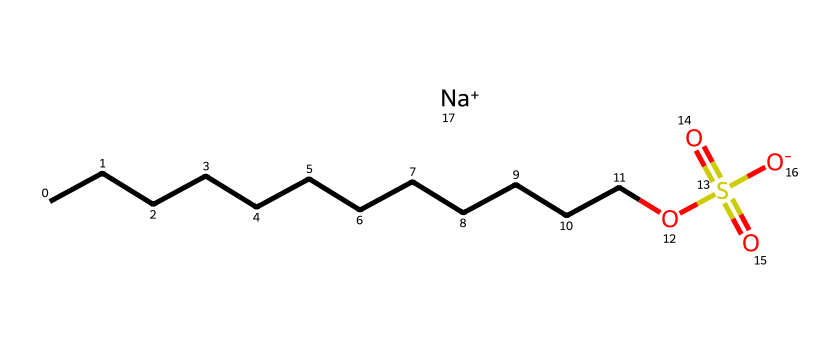What is the total number of carbon atoms in sodium lauryl sulfate? The chemical formula shows a long hydrocarbon chain with 12 carbon atoms (indicated by "CCCCCCCCCCCC").
Answer: 12 How many oxygen atoms are present in this compound? The structure has three oxygen atoms (one in the sulfonate group and two in the sulfate group).
Answer: 3 What type of functional group is represented in this chemical? The presence of the "OS(=O)(=O)" part indicates that the compound has a sulfonate functional group.
Answer: sulfonate What is the charge of the sodium ion in this compound? The chemical contains "Na+" which indicates that the sodium ion has a positive charge.
Answer: +1 What characteristic property does this detergent exhibit due to its structure? The long hydrophobic carbon chain and polar sulfonate group allow it to function as an emulsifier, helping to mix oil and water.
Answer: emulsifying agent What is the significance of the sodium ion in sodium lauryl sulfate? The sodium ion helps stabilize the compound and enhances its solubility in water, making it effective as a detergent.
Answer: stabilizes solubility What is the main role of the hydrophobic part of this detergent? The long carbon chain (hydrophobic part) helps to trap and remove grease and oils during cleaning processes.
Answer: grease removal 